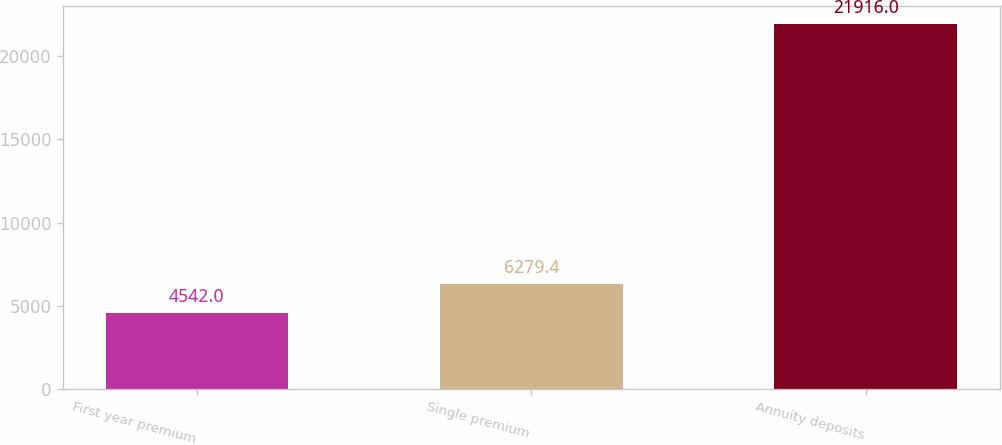<chart> <loc_0><loc_0><loc_500><loc_500><bar_chart><fcel>First year premium<fcel>Single premium<fcel>Annuity deposits<nl><fcel>4542<fcel>6279.4<fcel>21916<nl></chart> 